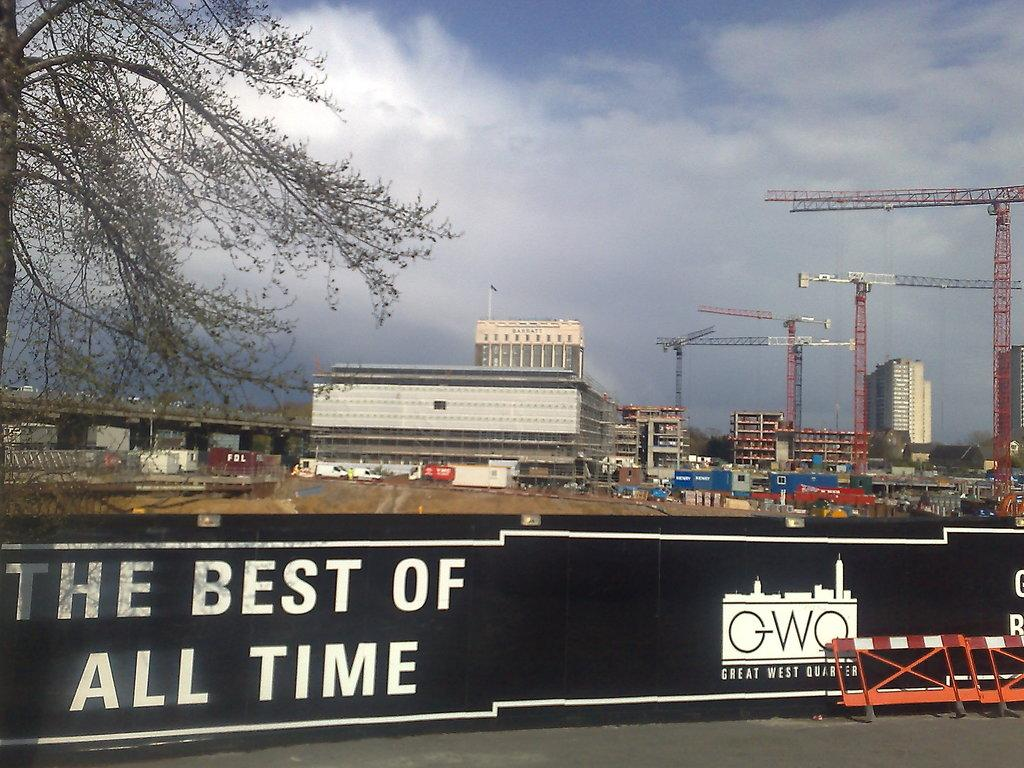<image>
Present a compact description of the photo's key features. A building site for Great West Quater is surrounded with black fencing. 